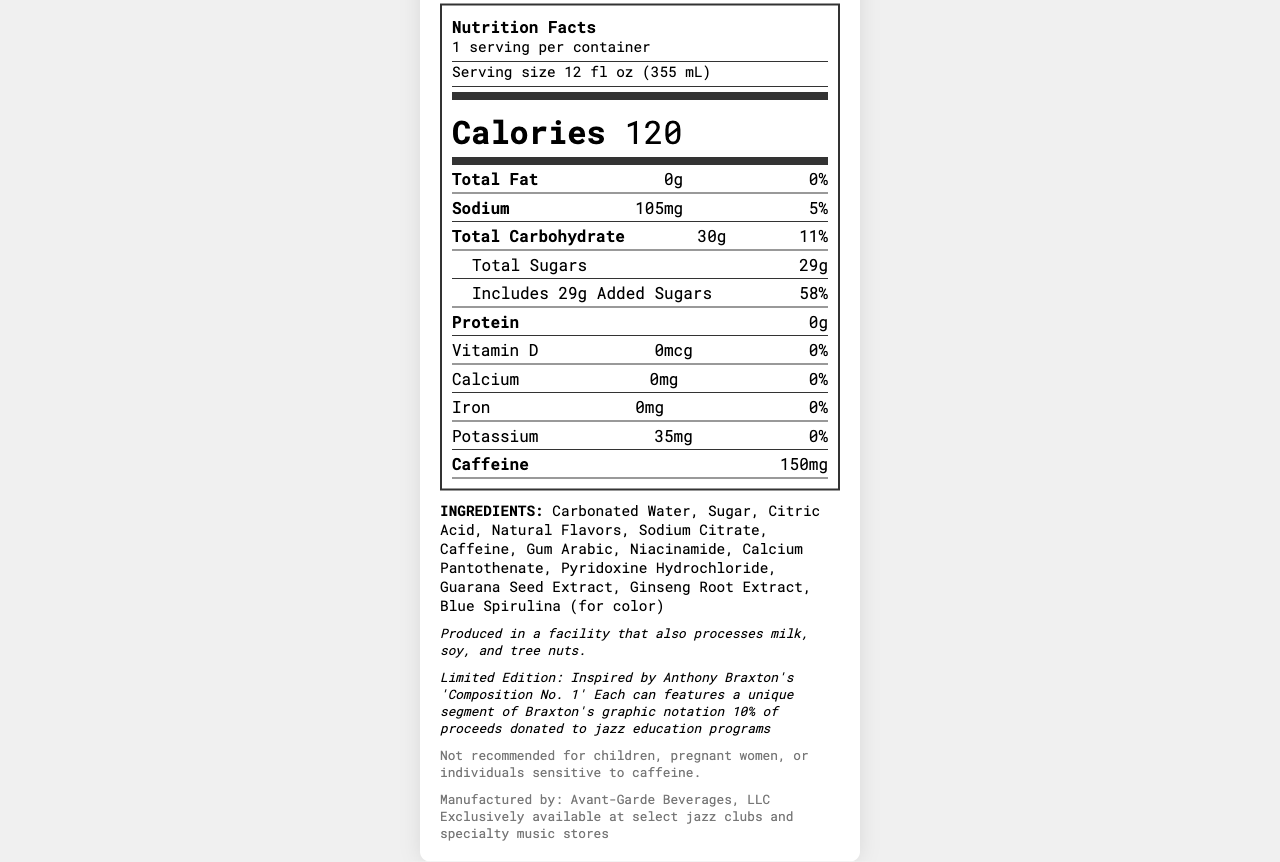what is the product name? The product name is listed at the top of the document under the header "Nutrition Facts: Braxton's Avant-Jazz Fusion".
Answer: Braxton's Avant-Jazz Fusion how many calories are in a serving? The number of calories is clearly indicated in the "Calories" section of the nutritional information.
Answer: 120 what is the serving size? The serving size is mentioned in the section "Serving size 12 fl oz (355 mL)".
Answer: 12 fl oz (355 mL) what is the amount of caffeine in the drink? The amount of caffeine is listed in the nutrition facts under "Caffeine".
Answer: 150mg what percentage of the daily value for added sugars does this drink provide? The daily value percentage for added sugars is shown as 58% in the section listing added sugars.
Answer: 58% how much sodium does one serving contain? A. 50mg B. 105mg C. 200mg The amount of sodium per serving is listed as 105mg in the nutrition facts.
Answer: B how much iron is in the drink? A. 2mg B. 10mg C. 0mg The amount of iron per serving is listed as 0mg in the nutrition facts.
Answer: C is the drink recommended for children? The disclaimer section states that the drink is not recommended for children, pregnant women, or individuals sensitive to caffeine.
Answer: No does the product contain any protein? The amount of protein is listed as 0g in the nutrition facts.
Answer: No what are some key nutritional components of the drink? These components are all listed in the nutrition facts section.
Answer: Calories, Total Fat, Sodium, Total Carbohydrate, Total Sugars, Protein, Vitamin D, Calcium, Iron, Potassium, Caffeine is the product high in added sugars? The amount of added sugars is 29g which provides 58% of the daily value, indicating it is high in added sugars.
Answer: Yes what is unique about this limited edition drink? The additional information section details these unique features.
Answer: It features Anthony Braxton's face on the packaging and each can includes a unique segment of his graphic notation. where is the drink available for purchase? The distribution information states that the drink is exclusively available at these locations.
Answer: Exclusively at select jazz clubs and specialty music stores what are the allergen warnings for this product? The allergen information is included in the additional info section.
Answer: Produced in a facility that also processes milk, soy, and tree nuts how many servings are in one container? The document states that there is 1 serving per container.
Answer: 1 how does the drink support jazz education? The additional info section indicates that 10% of proceeds will be donated.
Answer: 10% of proceeds donated to jazz education programs who manufactures the drink? The manufacturer is listed at the end of the document.
Answer: Avant-Garde Beverages, LLC summarize the main idea of the document. The label provides detailed nutritional information, ingredients, and special features associated with the drink, making it clear that this product merges jazz culture with a unique beverage experience.
Answer: The document is a Nutrition Facts Label for a limited edition energy drink named "Braxton's Avant-Jazz Fusion" inspired by Anthony Braxton, providing nutritional details, ingredients, allergen info, and additional information about the product's unique features and charitable contributions. what is the purpose of the blue spirulina in the ingredients? The document lists blue spirulina among the ingredients but does not explain its specific purpose.
Answer: Not enough information 